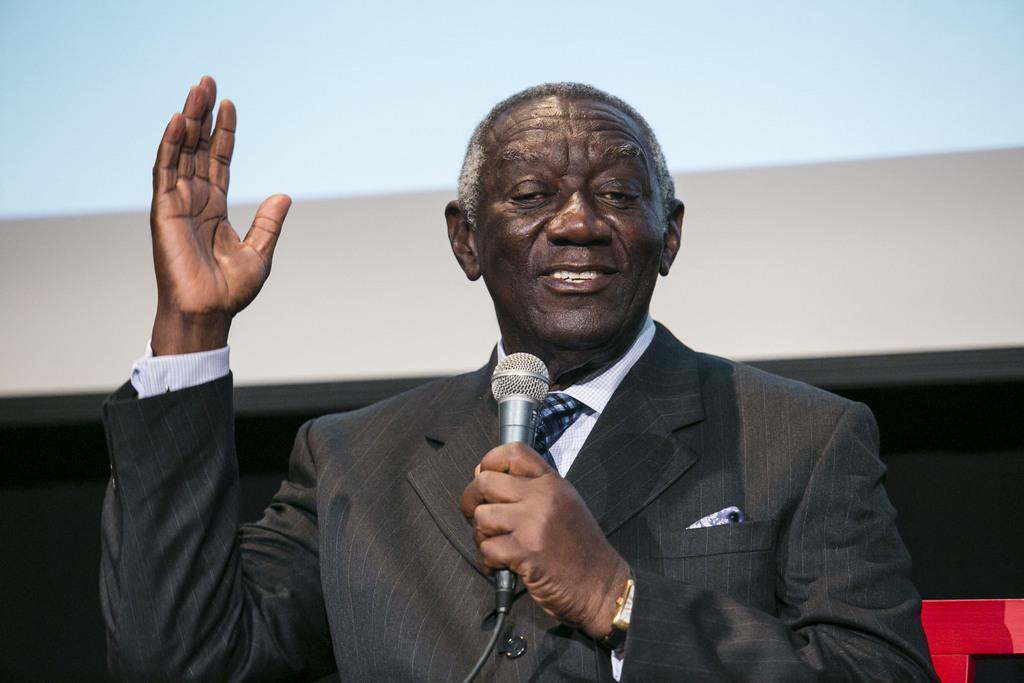In one or two sentences, can you explain what this image depicts? There is a man who is talking on the mike. He is in a suit. And on the background there is a screen. 